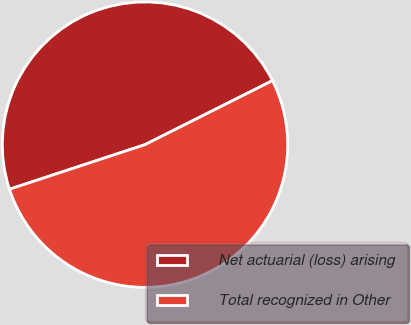<chart> <loc_0><loc_0><loc_500><loc_500><pie_chart><fcel>Net actuarial (loss) arising<fcel>Total recognized in Other<nl><fcel>47.65%<fcel>52.35%<nl></chart> 